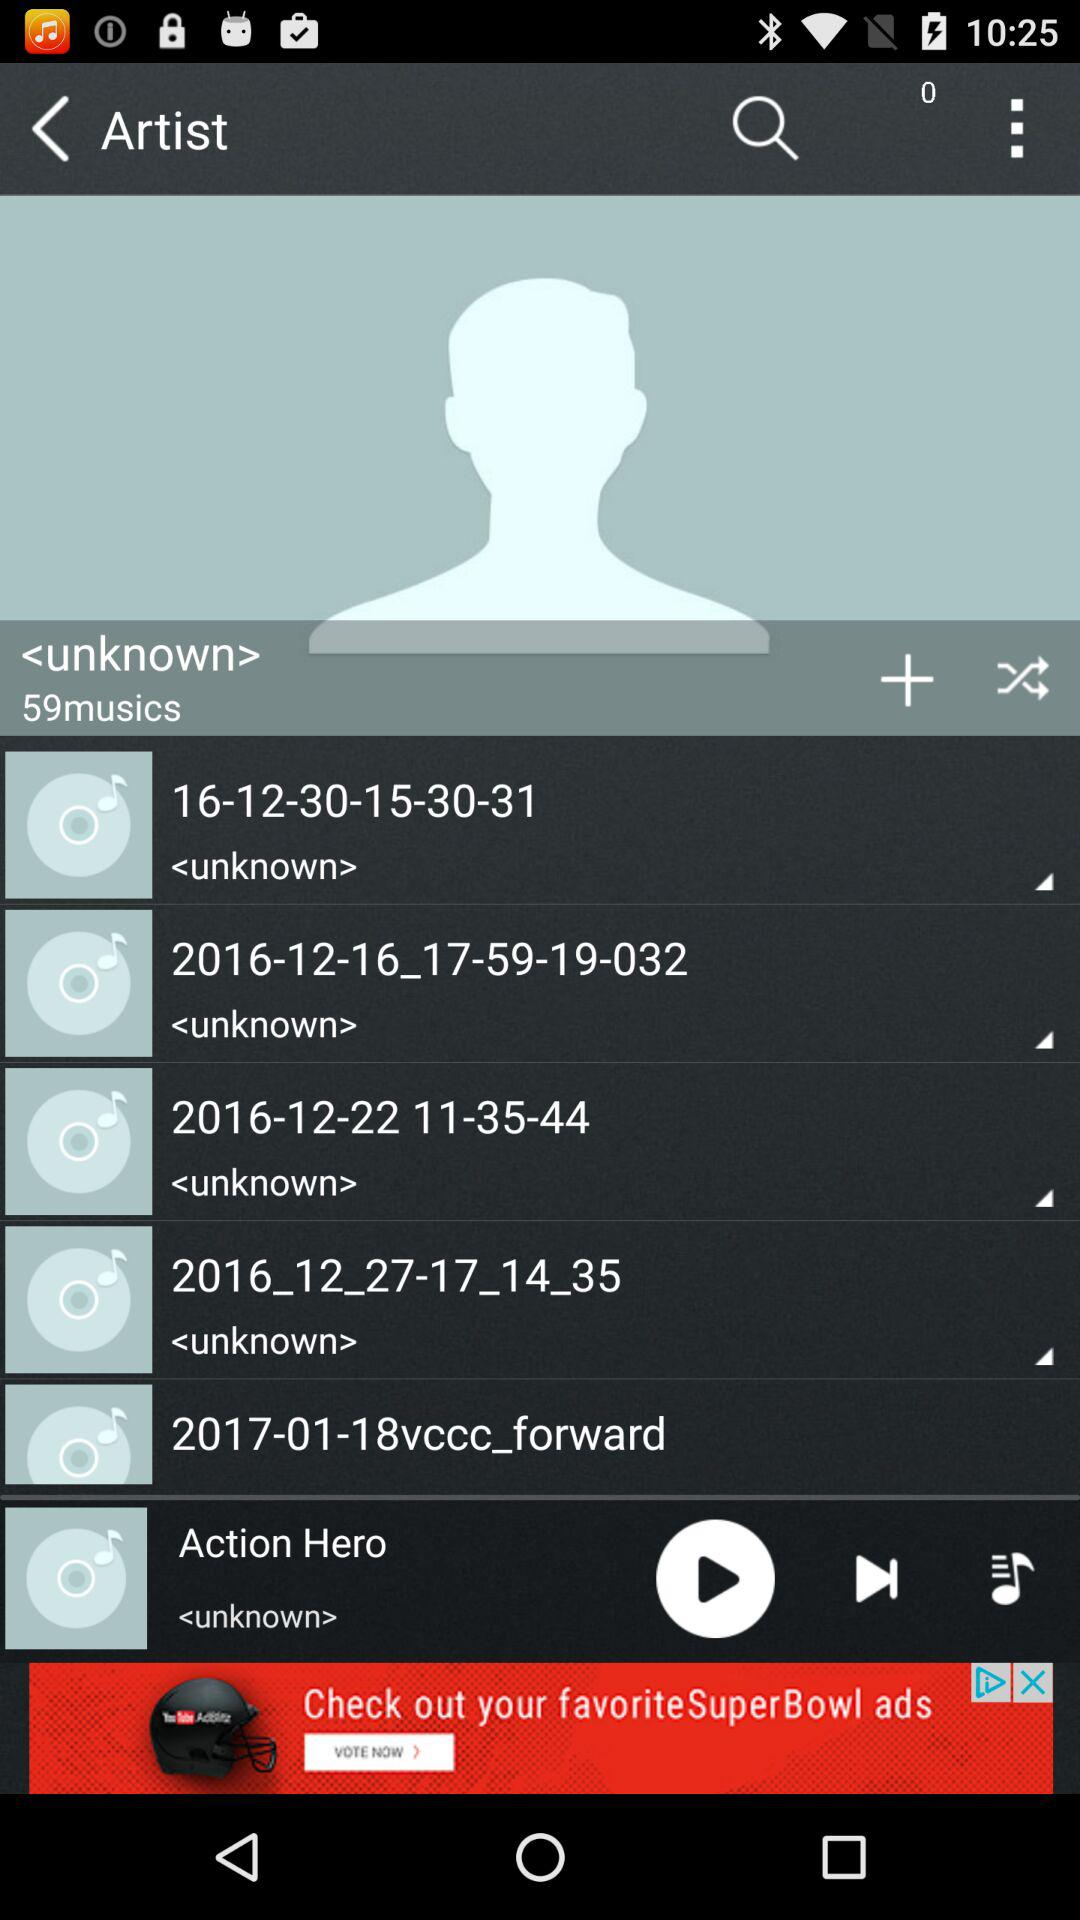How many music in total are there by unknown artists? There are 59 music by unknown artists. 